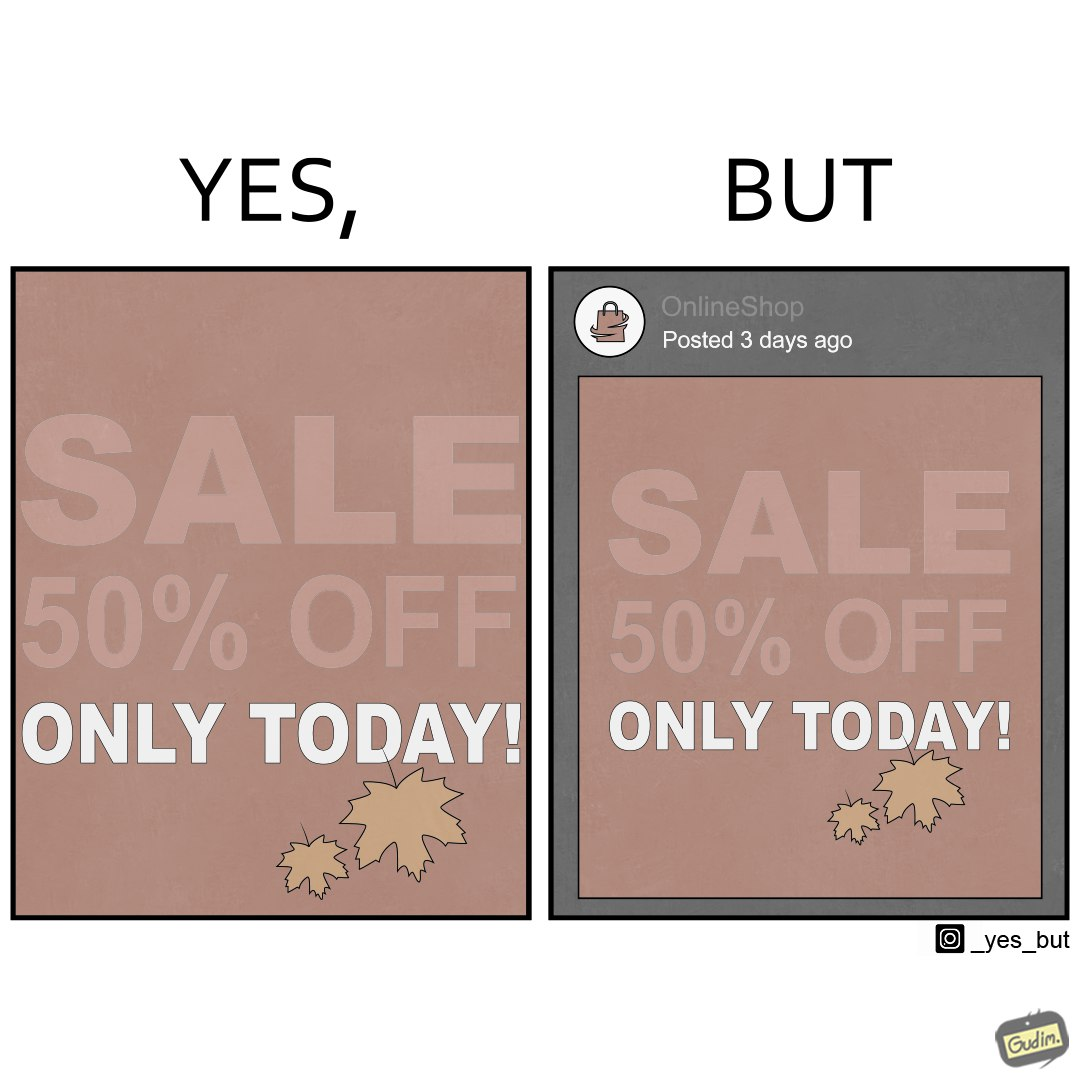What is shown in this image? The image is ironic, because the poster of sale at a store is posted 3 days ago on a social media account which means the sale which was for only one day has become over 